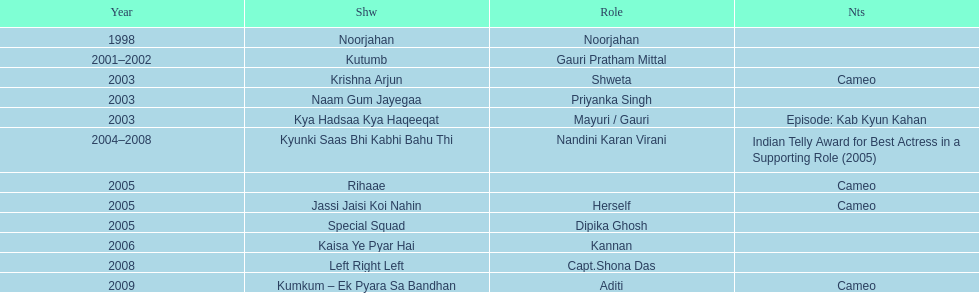In how many various tv programs did gauri tejwani appear before 2000? 1. 